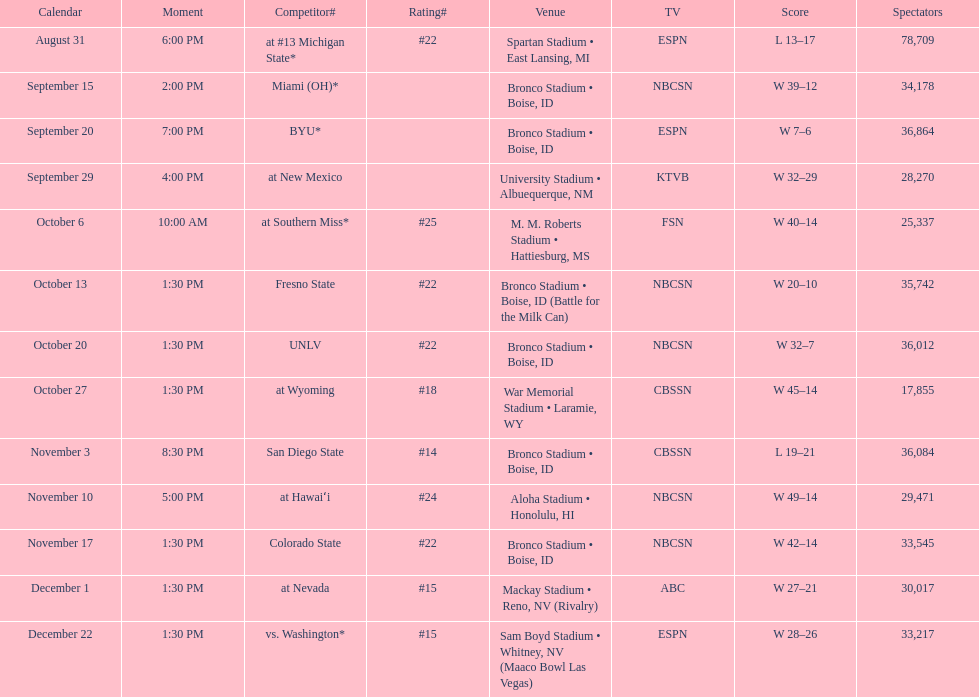Opponent broncos faced next after unlv Wyoming. 